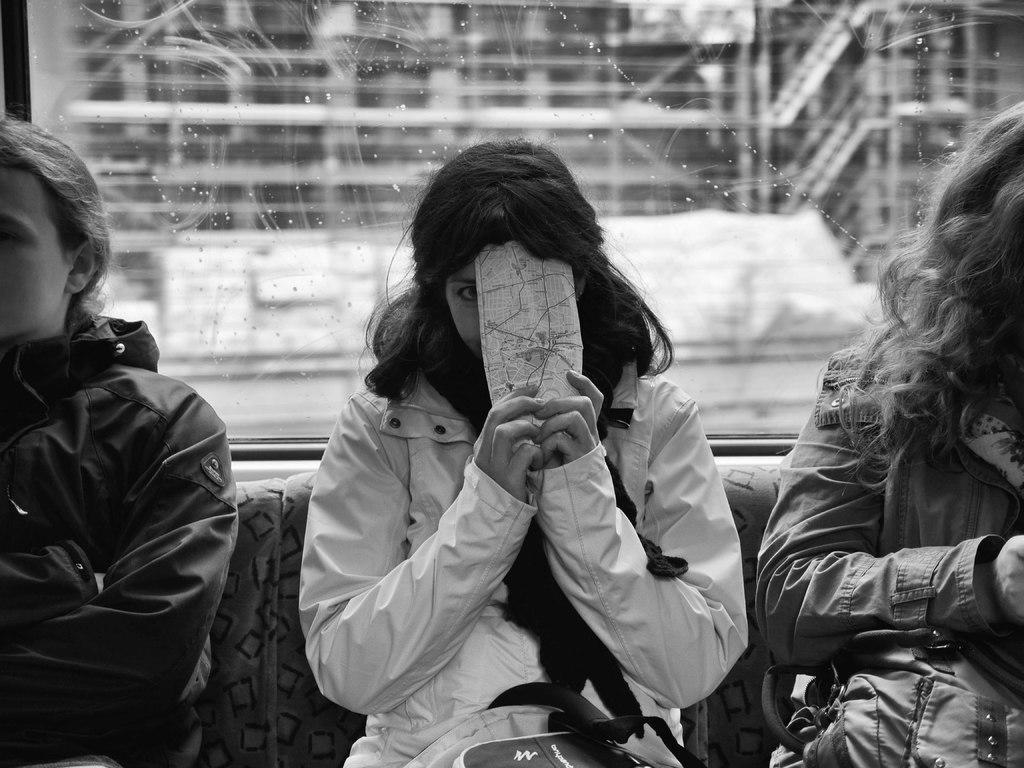Could you give a brief overview of what you see in this image? In this picture we can see few people are sitting, among them one woman is holding paper, behind we can see a glass. 